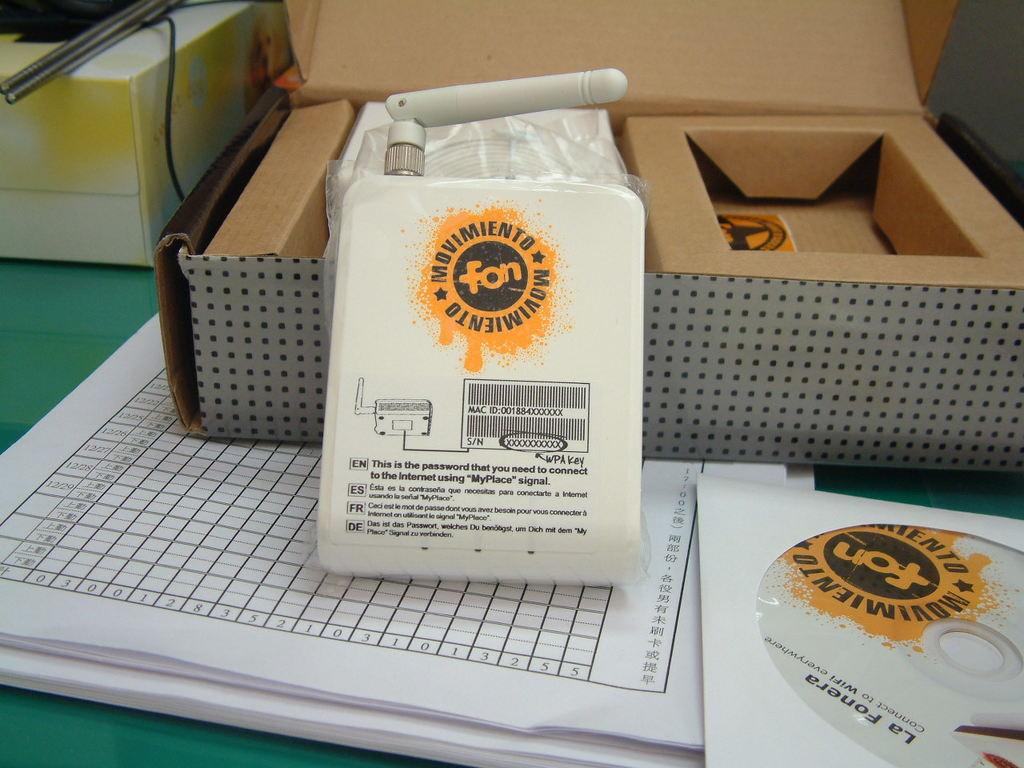What is the 3 letter word printed on the center of the yellow logo?
Ensure brevity in your answer.  Fon. 